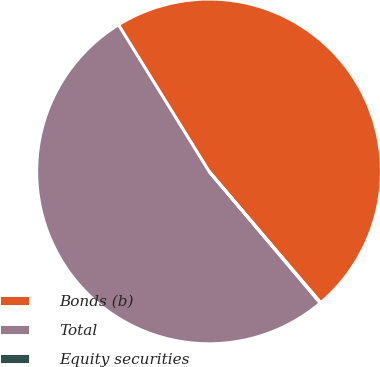Convert chart. <chart><loc_0><loc_0><loc_500><loc_500><pie_chart><fcel>Bonds (b)<fcel>Total<fcel>Equity securities<nl><fcel>47.59%<fcel>52.35%<fcel>0.06%<nl></chart> 